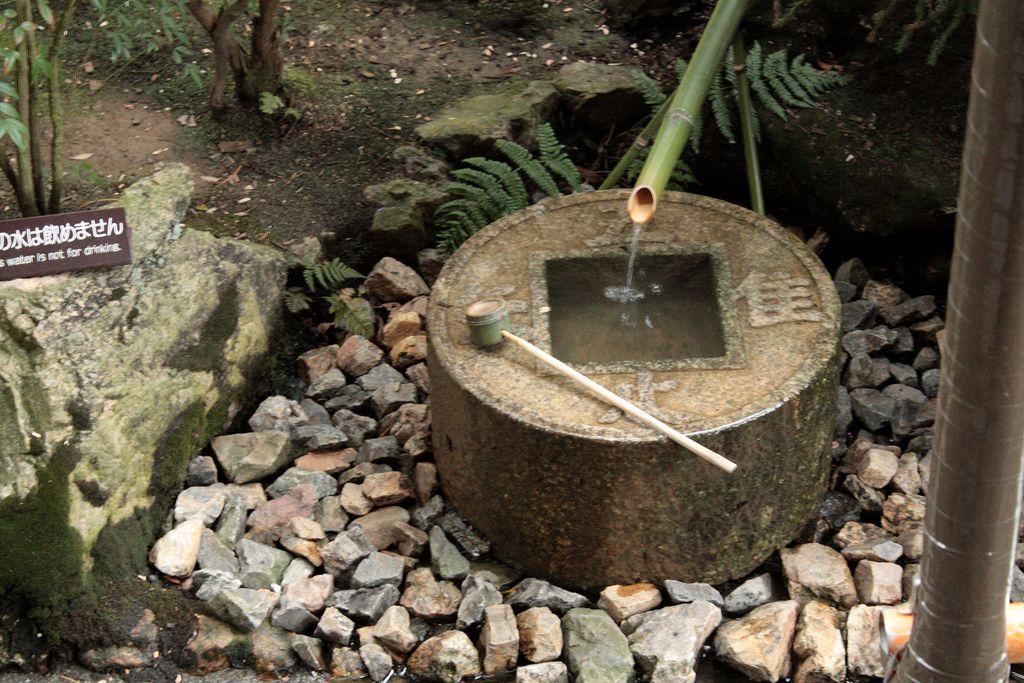In one or two sentences, can you explain what this image depicts? In the image there is a bamboo tap and the water is flowing from the tap into a hole in between a cement object and around that object there are lot of stones and few plants. 